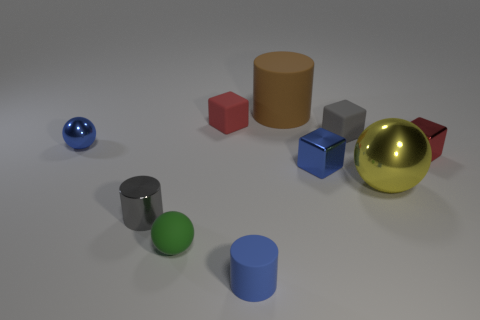Subtract all gray matte blocks. How many blocks are left? 3 Subtract all balls. How many objects are left? 7 Subtract 1 blocks. How many blocks are left? 3 Subtract all brown cylinders. Subtract all gray blocks. How many cylinders are left? 2 Subtract all purple cubes. How many red cylinders are left? 0 Subtract all tiny rubber balls. Subtract all blue metallic spheres. How many objects are left? 8 Add 6 gray matte blocks. How many gray matte blocks are left? 7 Add 9 tiny green spheres. How many tiny green spheres exist? 10 Subtract all blue cylinders. How many cylinders are left? 2 Subtract 1 blue balls. How many objects are left? 9 